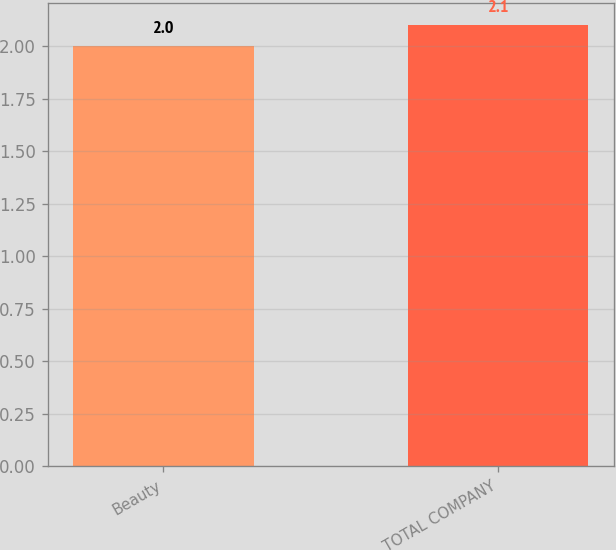<chart> <loc_0><loc_0><loc_500><loc_500><bar_chart><fcel>Beauty<fcel>TOTAL COMPANY<nl><fcel>2<fcel>2.1<nl></chart> 